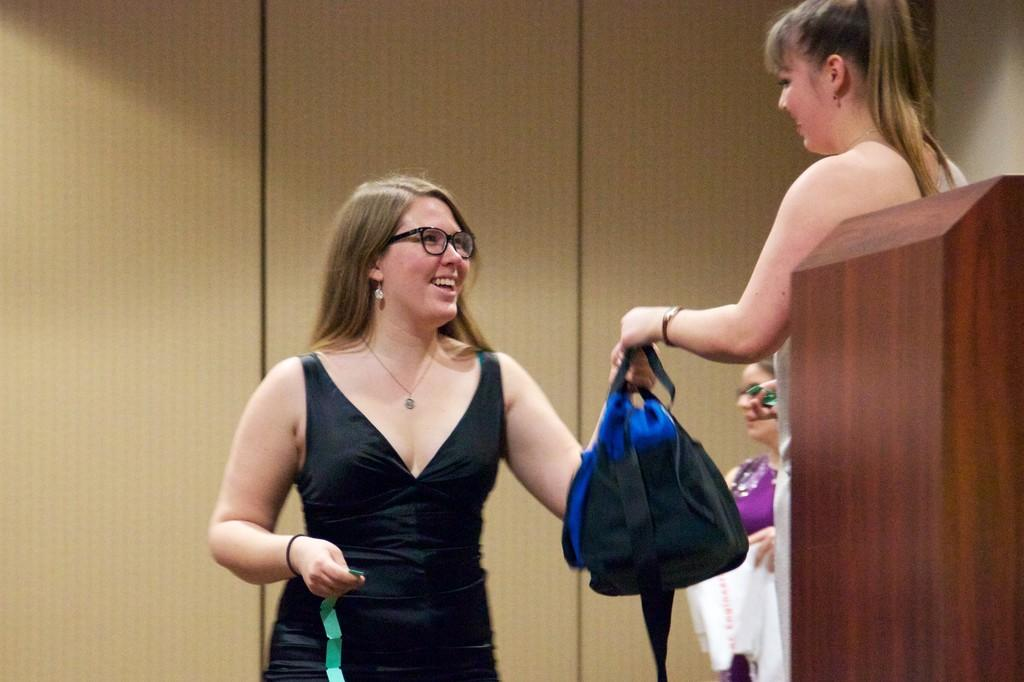How many people are in the image? There are three persons in the image. What object can be seen in the image besides the people? There is a bag in the image. What structure is located on the right side of the image? There appears to be a podium on the right side of the image. What type of furniture can be seen in the background of the image? There are cupboards visible in the background of the image. Are there any dogs or snakes visible in the image? No, there are no dogs or snakes present in the image. What type of ice can be seen melting on the podium in the image? There is no ice present in the image; it only features three persons, a bag, a podium, and cupboards. 